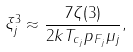<formula> <loc_0><loc_0><loc_500><loc_500>\xi _ { j } ^ { 3 } \approx \frac { 7 \zeta ( 3 ) } { 2 k T _ { c _ { j } } p _ { F _ { j } } \mu _ { j } } ,</formula> 